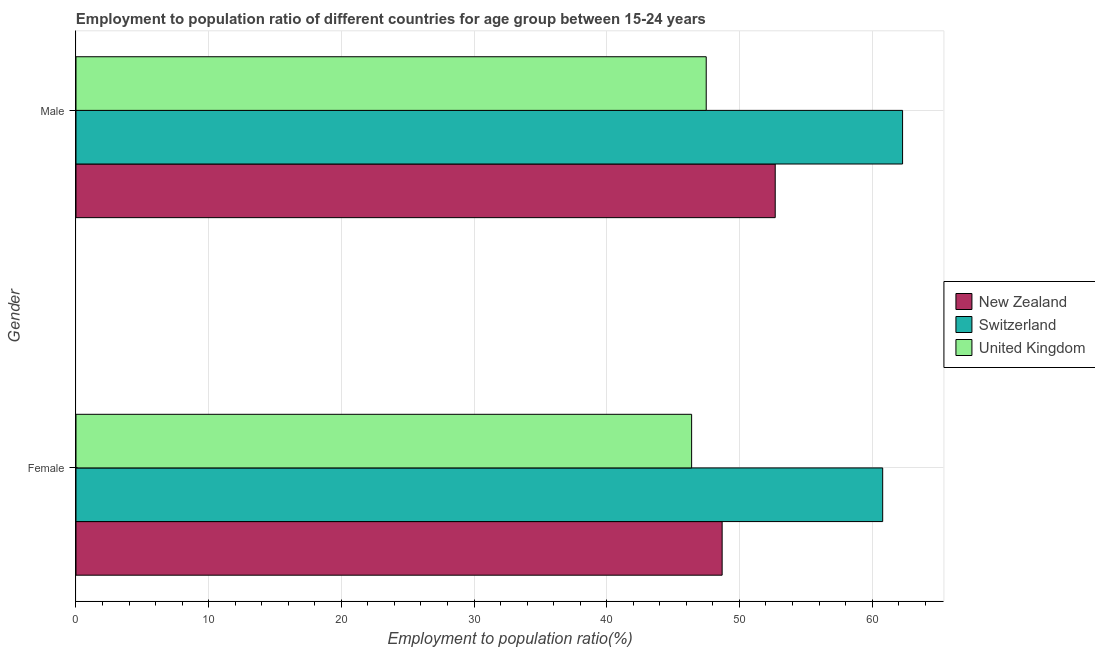How many bars are there on the 1st tick from the top?
Give a very brief answer. 3. How many bars are there on the 2nd tick from the bottom?
Offer a terse response. 3. What is the label of the 1st group of bars from the top?
Your answer should be compact. Male. What is the employment to population ratio(female) in Switzerland?
Make the answer very short. 60.8. Across all countries, what is the maximum employment to population ratio(female)?
Your answer should be very brief. 60.8. Across all countries, what is the minimum employment to population ratio(female)?
Offer a terse response. 46.4. In which country was the employment to population ratio(female) maximum?
Offer a very short reply. Switzerland. In which country was the employment to population ratio(male) minimum?
Give a very brief answer. United Kingdom. What is the total employment to population ratio(male) in the graph?
Make the answer very short. 162.5. What is the difference between the employment to population ratio(male) in Switzerland and that in United Kingdom?
Ensure brevity in your answer.  14.8. What is the difference between the employment to population ratio(female) in New Zealand and the employment to population ratio(male) in United Kingdom?
Your answer should be compact. 1.2. What is the average employment to population ratio(male) per country?
Offer a terse response. 54.17. What is the ratio of the employment to population ratio(female) in Switzerland to that in New Zealand?
Provide a succinct answer. 1.25. Is the employment to population ratio(female) in New Zealand less than that in United Kingdom?
Make the answer very short. No. What does the 2nd bar from the top in Male represents?
Offer a terse response. Switzerland. What does the 2nd bar from the bottom in Female represents?
Provide a succinct answer. Switzerland. Are all the bars in the graph horizontal?
Provide a succinct answer. Yes. What is the difference between two consecutive major ticks on the X-axis?
Your response must be concise. 10. Does the graph contain any zero values?
Provide a succinct answer. No. What is the title of the graph?
Provide a succinct answer. Employment to population ratio of different countries for age group between 15-24 years. Does "Lower middle income" appear as one of the legend labels in the graph?
Provide a short and direct response. No. What is the label or title of the X-axis?
Your answer should be compact. Employment to population ratio(%). What is the label or title of the Y-axis?
Keep it short and to the point. Gender. What is the Employment to population ratio(%) in New Zealand in Female?
Provide a short and direct response. 48.7. What is the Employment to population ratio(%) of Switzerland in Female?
Your response must be concise. 60.8. What is the Employment to population ratio(%) in United Kingdom in Female?
Make the answer very short. 46.4. What is the Employment to population ratio(%) in New Zealand in Male?
Offer a terse response. 52.7. What is the Employment to population ratio(%) of Switzerland in Male?
Your answer should be compact. 62.3. What is the Employment to population ratio(%) of United Kingdom in Male?
Ensure brevity in your answer.  47.5. Across all Gender, what is the maximum Employment to population ratio(%) of New Zealand?
Give a very brief answer. 52.7. Across all Gender, what is the maximum Employment to population ratio(%) in Switzerland?
Your answer should be very brief. 62.3. Across all Gender, what is the maximum Employment to population ratio(%) in United Kingdom?
Give a very brief answer. 47.5. Across all Gender, what is the minimum Employment to population ratio(%) in New Zealand?
Offer a terse response. 48.7. Across all Gender, what is the minimum Employment to population ratio(%) of Switzerland?
Ensure brevity in your answer.  60.8. Across all Gender, what is the minimum Employment to population ratio(%) of United Kingdom?
Offer a very short reply. 46.4. What is the total Employment to population ratio(%) in New Zealand in the graph?
Give a very brief answer. 101.4. What is the total Employment to population ratio(%) in Switzerland in the graph?
Offer a terse response. 123.1. What is the total Employment to population ratio(%) in United Kingdom in the graph?
Keep it short and to the point. 93.9. What is the difference between the Employment to population ratio(%) of New Zealand in Female and that in Male?
Offer a very short reply. -4. What is the difference between the Employment to population ratio(%) of Switzerland in Female and that in Male?
Provide a short and direct response. -1.5. What is the difference between the Employment to population ratio(%) of New Zealand in Female and the Employment to population ratio(%) of Switzerland in Male?
Your answer should be compact. -13.6. What is the difference between the Employment to population ratio(%) of Switzerland in Female and the Employment to population ratio(%) of United Kingdom in Male?
Offer a terse response. 13.3. What is the average Employment to population ratio(%) of New Zealand per Gender?
Ensure brevity in your answer.  50.7. What is the average Employment to population ratio(%) in Switzerland per Gender?
Provide a succinct answer. 61.55. What is the average Employment to population ratio(%) of United Kingdom per Gender?
Ensure brevity in your answer.  46.95. What is the difference between the Employment to population ratio(%) of New Zealand and Employment to population ratio(%) of United Kingdom in Female?
Your answer should be compact. 2.3. What is the difference between the Employment to population ratio(%) in Switzerland and Employment to population ratio(%) in United Kingdom in Male?
Provide a succinct answer. 14.8. What is the ratio of the Employment to population ratio(%) in New Zealand in Female to that in Male?
Give a very brief answer. 0.92. What is the ratio of the Employment to population ratio(%) of Switzerland in Female to that in Male?
Give a very brief answer. 0.98. What is the ratio of the Employment to population ratio(%) in United Kingdom in Female to that in Male?
Offer a very short reply. 0.98. What is the difference between the highest and the second highest Employment to population ratio(%) of New Zealand?
Ensure brevity in your answer.  4. What is the difference between the highest and the second highest Employment to population ratio(%) of United Kingdom?
Make the answer very short. 1.1. What is the difference between the highest and the lowest Employment to population ratio(%) in New Zealand?
Offer a very short reply. 4. What is the difference between the highest and the lowest Employment to population ratio(%) of Switzerland?
Provide a short and direct response. 1.5. 